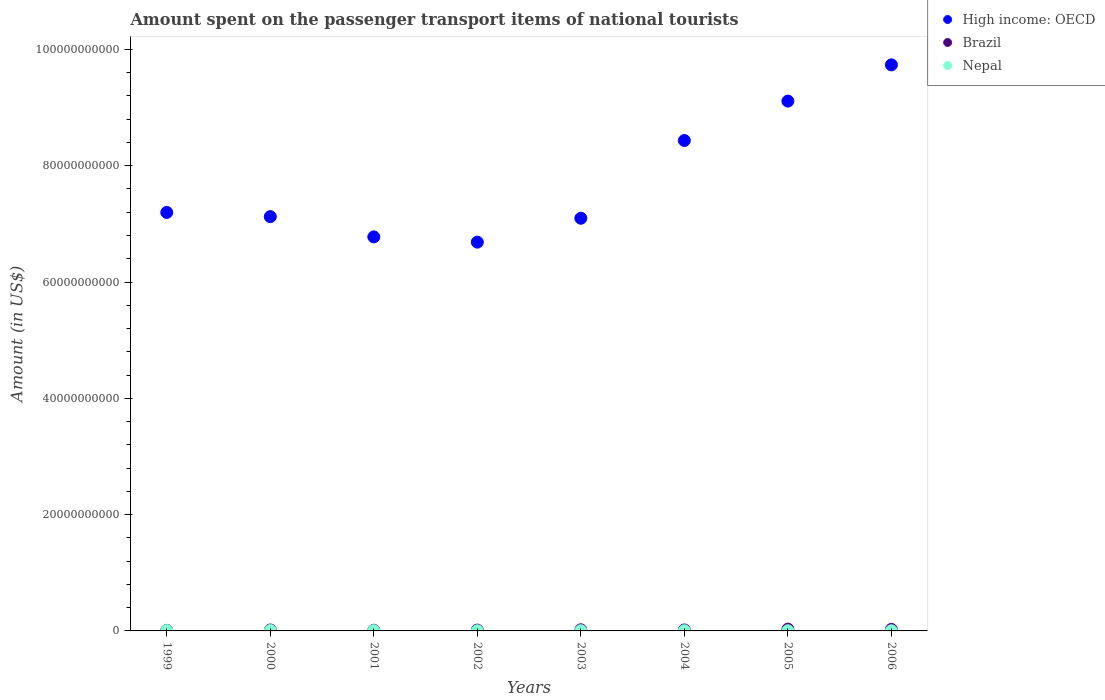Is the number of dotlines equal to the number of legend labels?
Provide a short and direct response. Yes. What is the amount spent on the passenger transport items of national tourists in High income: OECD in 2005?
Ensure brevity in your answer.  9.11e+1. Across all years, what is the maximum amount spent on the passenger transport items of national tourists in Nepal?
Offer a very short reply. 6.10e+07. Across all years, what is the minimum amount spent on the passenger transport items of national tourists in High income: OECD?
Keep it short and to the point. 6.69e+1. In which year was the amount spent on the passenger transport items of national tourists in Brazil maximum?
Offer a very short reply. 2005. What is the total amount spent on the passenger transport items of national tourists in Nepal in the graph?
Your answer should be compact. 3.16e+08. What is the difference between the amount spent on the passenger transport items of national tourists in Nepal in 2003 and that in 2005?
Provide a short and direct response. 4.00e+06. What is the difference between the amount spent on the passenger transport items of national tourists in Nepal in 2004 and the amount spent on the passenger transport items of national tourists in Brazil in 2003?
Your answer should be compact. -1.64e+08. What is the average amount spent on the passenger transport items of national tourists in Nepal per year?
Offer a very short reply. 3.95e+07. In the year 2003, what is the difference between the amount spent on the passenger transport items of national tourists in Brazil and amount spent on the passenger transport items of national tourists in High income: OECD?
Your answer should be compact. -7.08e+1. What is the ratio of the amount spent on the passenger transport items of national tourists in Nepal in 2002 to that in 2004?
Provide a short and direct response. 1.03. Is the amount spent on the passenger transport items of national tourists in High income: OECD in 2002 less than that in 2006?
Your answer should be compact. Yes. What is the difference between the highest and the second highest amount spent on the passenger transport items of national tourists in Nepal?
Make the answer very short. 5.00e+06. What is the difference between the highest and the lowest amount spent on the passenger transport items of national tourists in Nepal?
Your answer should be very brief. 3.20e+07. In how many years, is the amount spent on the passenger transport items of national tourists in High income: OECD greater than the average amount spent on the passenger transport items of national tourists in High income: OECD taken over all years?
Your response must be concise. 3. Is it the case that in every year, the sum of the amount spent on the passenger transport items of national tourists in Nepal and amount spent on the passenger transport items of national tourists in Brazil  is greater than the amount spent on the passenger transport items of national tourists in High income: OECD?
Offer a very short reply. No. Does the amount spent on the passenger transport items of national tourists in Brazil monotonically increase over the years?
Keep it short and to the point. No. Is the amount spent on the passenger transport items of national tourists in Brazil strictly greater than the amount spent on the passenger transport items of national tourists in High income: OECD over the years?
Provide a succinct answer. No. Is the amount spent on the passenger transport items of national tourists in Nepal strictly less than the amount spent on the passenger transport items of national tourists in Brazil over the years?
Your answer should be compact. Yes. How many dotlines are there?
Offer a very short reply. 3. Does the graph contain any zero values?
Ensure brevity in your answer.  No. Where does the legend appear in the graph?
Your answer should be very brief. Top right. How are the legend labels stacked?
Your response must be concise. Vertical. What is the title of the graph?
Your response must be concise. Amount spent on the passenger transport items of national tourists. Does "Upper middle income" appear as one of the legend labels in the graph?
Offer a very short reply. No. What is the label or title of the X-axis?
Provide a succinct answer. Years. What is the Amount (in US$) in High income: OECD in 1999?
Provide a succinct answer. 7.20e+1. What is the Amount (in US$) in Brazil in 1999?
Keep it short and to the point. 9.20e+07. What is the Amount (in US$) in Nepal in 1999?
Keep it short and to the point. 5.60e+07. What is the Amount (in US$) of High income: OECD in 2000?
Provide a short and direct response. 7.12e+1. What is the Amount (in US$) of Brazil in 2000?
Offer a very short reply. 1.59e+08. What is the Amount (in US$) in Nepal in 2000?
Your answer should be very brief. 6.10e+07. What is the Amount (in US$) in High income: OECD in 2001?
Keep it short and to the point. 6.78e+1. What is the Amount (in US$) in Brazil in 2001?
Make the answer very short. 1.13e+08. What is the Amount (in US$) in Nepal in 2001?
Offer a very short reply. 4.70e+07. What is the Amount (in US$) of High income: OECD in 2002?
Offer a very short reply. 6.69e+1. What is the Amount (in US$) of Brazil in 2002?
Keep it short and to the point. 1.44e+08. What is the Amount (in US$) of Nepal in 2002?
Your answer should be very brief. 3.10e+07. What is the Amount (in US$) of High income: OECD in 2003?
Your answer should be compact. 7.10e+1. What is the Amount (in US$) of Brazil in 2003?
Your answer should be compact. 1.94e+08. What is the Amount (in US$) in Nepal in 2003?
Ensure brevity in your answer.  3.30e+07. What is the Amount (in US$) in High income: OECD in 2004?
Your answer should be very brief. 8.43e+1. What is the Amount (in US$) in Brazil in 2004?
Ensure brevity in your answer.  1.67e+08. What is the Amount (in US$) in Nepal in 2004?
Keep it short and to the point. 3.00e+07. What is the Amount (in US$) in High income: OECD in 2005?
Your answer should be very brief. 9.11e+1. What is the Amount (in US$) of Brazil in 2005?
Keep it short and to the point. 3.07e+08. What is the Amount (in US$) of Nepal in 2005?
Offer a terse response. 2.90e+07. What is the Amount (in US$) in High income: OECD in 2006?
Offer a terse response. 9.73e+1. What is the Amount (in US$) in Brazil in 2006?
Offer a very short reply. 2.61e+08. What is the Amount (in US$) of Nepal in 2006?
Keep it short and to the point. 2.90e+07. Across all years, what is the maximum Amount (in US$) in High income: OECD?
Provide a succinct answer. 9.73e+1. Across all years, what is the maximum Amount (in US$) of Brazil?
Your answer should be very brief. 3.07e+08. Across all years, what is the maximum Amount (in US$) of Nepal?
Make the answer very short. 6.10e+07. Across all years, what is the minimum Amount (in US$) in High income: OECD?
Give a very brief answer. 6.69e+1. Across all years, what is the minimum Amount (in US$) of Brazil?
Your response must be concise. 9.20e+07. Across all years, what is the minimum Amount (in US$) of Nepal?
Your answer should be compact. 2.90e+07. What is the total Amount (in US$) in High income: OECD in the graph?
Provide a succinct answer. 6.22e+11. What is the total Amount (in US$) of Brazil in the graph?
Your answer should be compact. 1.44e+09. What is the total Amount (in US$) in Nepal in the graph?
Ensure brevity in your answer.  3.16e+08. What is the difference between the Amount (in US$) in High income: OECD in 1999 and that in 2000?
Your response must be concise. 7.22e+08. What is the difference between the Amount (in US$) in Brazil in 1999 and that in 2000?
Ensure brevity in your answer.  -6.70e+07. What is the difference between the Amount (in US$) of Nepal in 1999 and that in 2000?
Your response must be concise. -5.00e+06. What is the difference between the Amount (in US$) of High income: OECD in 1999 and that in 2001?
Provide a succinct answer. 4.20e+09. What is the difference between the Amount (in US$) in Brazil in 1999 and that in 2001?
Provide a short and direct response. -2.10e+07. What is the difference between the Amount (in US$) in Nepal in 1999 and that in 2001?
Give a very brief answer. 9.00e+06. What is the difference between the Amount (in US$) in High income: OECD in 1999 and that in 2002?
Offer a very short reply. 5.10e+09. What is the difference between the Amount (in US$) of Brazil in 1999 and that in 2002?
Offer a very short reply. -5.20e+07. What is the difference between the Amount (in US$) of Nepal in 1999 and that in 2002?
Give a very brief answer. 2.50e+07. What is the difference between the Amount (in US$) of High income: OECD in 1999 and that in 2003?
Offer a very short reply. 9.96e+08. What is the difference between the Amount (in US$) of Brazil in 1999 and that in 2003?
Make the answer very short. -1.02e+08. What is the difference between the Amount (in US$) of Nepal in 1999 and that in 2003?
Offer a very short reply. 2.30e+07. What is the difference between the Amount (in US$) of High income: OECD in 1999 and that in 2004?
Provide a succinct answer. -1.24e+1. What is the difference between the Amount (in US$) in Brazil in 1999 and that in 2004?
Offer a terse response. -7.50e+07. What is the difference between the Amount (in US$) of Nepal in 1999 and that in 2004?
Offer a very short reply. 2.60e+07. What is the difference between the Amount (in US$) of High income: OECD in 1999 and that in 2005?
Ensure brevity in your answer.  -1.91e+1. What is the difference between the Amount (in US$) in Brazil in 1999 and that in 2005?
Ensure brevity in your answer.  -2.15e+08. What is the difference between the Amount (in US$) in Nepal in 1999 and that in 2005?
Offer a terse response. 2.70e+07. What is the difference between the Amount (in US$) of High income: OECD in 1999 and that in 2006?
Offer a very short reply. -2.54e+1. What is the difference between the Amount (in US$) of Brazil in 1999 and that in 2006?
Offer a terse response. -1.69e+08. What is the difference between the Amount (in US$) of Nepal in 1999 and that in 2006?
Make the answer very short. 2.70e+07. What is the difference between the Amount (in US$) in High income: OECD in 2000 and that in 2001?
Your response must be concise. 3.48e+09. What is the difference between the Amount (in US$) in Brazil in 2000 and that in 2001?
Keep it short and to the point. 4.60e+07. What is the difference between the Amount (in US$) of Nepal in 2000 and that in 2001?
Make the answer very short. 1.40e+07. What is the difference between the Amount (in US$) in High income: OECD in 2000 and that in 2002?
Offer a terse response. 4.38e+09. What is the difference between the Amount (in US$) in Brazil in 2000 and that in 2002?
Your response must be concise. 1.50e+07. What is the difference between the Amount (in US$) in Nepal in 2000 and that in 2002?
Provide a succinct answer. 3.00e+07. What is the difference between the Amount (in US$) in High income: OECD in 2000 and that in 2003?
Your answer should be very brief. 2.74e+08. What is the difference between the Amount (in US$) of Brazil in 2000 and that in 2003?
Provide a short and direct response. -3.50e+07. What is the difference between the Amount (in US$) of Nepal in 2000 and that in 2003?
Your response must be concise. 2.80e+07. What is the difference between the Amount (in US$) in High income: OECD in 2000 and that in 2004?
Offer a terse response. -1.31e+1. What is the difference between the Amount (in US$) of Brazil in 2000 and that in 2004?
Provide a short and direct response. -8.00e+06. What is the difference between the Amount (in US$) in Nepal in 2000 and that in 2004?
Make the answer very short. 3.10e+07. What is the difference between the Amount (in US$) of High income: OECD in 2000 and that in 2005?
Provide a short and direct response. -1.99e+1. What is the difference between the Amount (in US$) in Brazil in 2000 and that in 2005?
Keep it short and to the point. -1.48e+08. What is the difference between the Amount (in US$) of Nepal in 2000 and that in 2005?
Your response must be concise. 3.20e+07. What is the difference between the Amount (in US$) of High income: OECD in 2000 and that in 2006?
Keep it short and to the point. -2.61e+1. What is the difference between the Amount (in US$) of Brazil in 2000 and that in 2006?
Your answer should be very brief. -1.02e+08. What is the difference between the Amount (in US$) of Nepal in 2000 and that in 2006?
Offer a terse response. 3.20e+07. What is the difference between the Amount (in US$) in High income: OECD in 2001 and that in 2002?
Provide a short and direct response. 9.02e+08. What is the difference between the Amount (in US$) of Brazil in 2001 and that in 2002?
Ensure brevity in your answer.  -3.10e+07. What is the difference between the Amount (in US$) of Nepal in 2001 and that in 2002?
Give a very brief answer. 1.60e+07. What is the difference between the Amount (in US$) in High income: OECD in 2001 and that in 2003?
Keep it short and to the point. -3.21e+09. What is the difference between the Amount (in US$) in Brazil in 2001 and that in 2003?
Ensure brevity in your answer.  -8.10e+07. What is the difference between the Amount (in US$) in Nepal in 2001 and that in 2003?
Offer a terse response. 1.40e+07. What is the difference between the Amount (in US$) in High income: OECD in 2001 and that in 2004?
Provide a short and direct response. -1.66e+1. What is the difference between the Amount (in US$) of Brazil in 2001 and that in 2004?
Offer a very short reply. -5.40e+07. What is the difference between the Amount (in US$) in Nepal in 2001 and that in 2004?
Offer a very short reply. 1.70e+07. What is the difference between the Amount (in US$) in High income: OECD in 2001 and that in 2005?
Make the answer very short. -2.34e+1. What is the difference between the Amount (in US$) in Brazil in 2001 and that in 2005?
Ensure brevity in your answer.  -1.94e+08. What is the difference between the Amount (in US$) in Nepal in 2001 and that in 2005?
Ensure brevity in your answer.  1.80e+07. What is the difference between the Amount (in US$) in High income: OECD in 2001 and that in 2006?
Offer a very short reply. -2.96e+1. What is the difference between the Amount (in US$) in Brazil in 2001 and that in 2006?
Give a very brief answer. -1.48e+08. What is the difference between the Amount (in US$) in Nepal in 2001 and that in 2006?
Ensure brevity in your answer.  1.80e+07. What is the difference between the Amount (in US$) of High income: OECD in 2002 and that in 2003?
Offer a terse response. -4.11e+09. What is the difference between the Amount (in US$) in Brazil in 2002 and that in 2003?
Offer a terse response. -5.00e+07. What is the difference between the Amount (in US$) in High income: OECD in 2002 and that in 2004?
Offer a very short reply. -1.75e+1. What is the difference between the Amount (in US$) in Brazil in 2002 and that in 2004?
Provide a short and direct response. -2.30e+07. What is the difference between the Amount (in US$) in High income: OECD in 2002 and that in 2005?
Provide a succinct answer. -2.43e+1. What is the difference between the Amount (in US$) in Brazil in 2002 and that in 2005?
Provide a short and direct response. -1.63e+08. What is the difference between the Amount (in US$) in High income: OECD in 2002 and that in 2006?
Provide a short and direct response. -3.05e+1. What is the difference between the Amount (in US$) of Brazil in 2002 and that in 2006?
Provide a succinct answer. -1.17e+08. What is the difference between the Amount (in US$) in Nepal in 2002 and that in 2006?
Provide a short and direct response. 2.00e+06. What is the difference between the Amount (in US$) in High income: OECD in 2003 and that in 2004?
Your answer should be very brief. -1.34e+1. What is the difference between the Amount (in US$) in Brazil in 2003 and that in 2004?
Give a very brief answer. 2.70e+07. What is the difference between the Amount (in US$) of High income: OECD in 2003 and that in 2005?
Offer a terse response. -2.01e+1. What is the difference between the Amount (in US$) in Brazil in 2003 and that in 2005?
Provide a succinct answer. -1.13e+08. What is the difference between the Amount (in US$) of High income: OECD in 2003 and that in 2006?
Provide a short and direct response. -2.64e+1. What is the difference between the Amount (in US$) in Brazil in 2003 and that in 2006?
Offer a very short reply. -6.70e+07. What is the difference between the Amount (in US$) of High income: OECD in 2004 and that in 2005?
Your answer should be compact. -6.77e+09. What is the difference between the Amount (in US$) in Brazil in 2004 and that in 2005?
Offer a terse response. -1.40e+08. What is the difference between the Amount (in US$) of High income: OECD in 2004 and that in 2006?
Give a very brief answer. -1.30e+1. What is the difference between the Amount (in US$) of Brazil in 2004 and that in 2006?
Keep it short and to the point. -9.40e+07. What is the difference between the Amount (in US$) in Nepal in 2004 and that in 2006?
Offer a very short reply. 1.00e+06. What is the difference between the Amount (in US$) of High income: OECD in 2005 and that in 2006?
Make the answer very short. -6.23e+09. What is the difference between the Amount (in US$) of Brazil in 2005 and that in 2006?
Make the answer very short. 4.60e+07. What is the difference between the Amount (in US$) in Nepal in 2005 and that in 2006?
Your response must be concise. 0. What is the difference between the Amount (in US$) of High income: OECD in 1999 and the Amount (in US$) of Brazil in 2000?
Your answer should be very brief. 7.18e+1. What is the difference between the Amount (in US$) of High income: OECD in 1999 and the Amount (in US$) of Nepal in 2000?
Ensure brevity in your answer.  7.19e+1. What is the difference between the Amount (in US$) of Brazil in 1999 and the Amount (in US$) of Nepal in 2000?
Provide a short and direct response. 3.10e+07. What is the difference between the Amount (in US$) of High income: OECD in 1999 and the Amount (in US$) of Brazil in 2001?
Offer a terse response. 7.19e+1. What is the difference between the Amount (in US$) in High income: OECD in 1999 and the Amount (in US$) in Nepal in 2001?
Give a very brief answer. 7.19e+1. What is the difference between the Amount (in US$) of Brazil in 1999 and the Amount (in US$) of Nepal in 2001?
Ensure brevity in your answer.  4.50e+07. What is the difference between the Amount (in US$) of High income: OECD in 1999 and the Amount (in US$) of Brazil in 2002?
Make the answer very short. 7.18e+1. What is the difference between the Amount (in US$) of High income: OECD in 1999 and the Amount (in US$) of Nepal in 2002?
Your response must be concise. 7.19e+1. What is the difference between the Amount (in US$) in Brazil in 1999 and the Amount (in US$) in Nepal in 2002?
Provide a succinct answer. 6.10e+07. What is the difference between the Amount (in US$) in High income: OECD in 1999 and the Amount (in US$) in Brazil in 2003?
Your answer should be compact. 7.18e+1. What is the difference between the Amount (in US$) of High income: OECD in 1999 and the Amount (in US$) of Nepal in 2003?
Offer a very short reply. 7.19e+1. What is the difference between the Amount (in US$) in Brazil in 1999 and the Amount (in US$) in Nepal in 2003?
Make the answer very short. 5.90e+07. What is the difference between the Amount (in US$) in High income: OECD in 1999 and the Amount (in US$) in Brazil in 2004?
Your answer should be compact. 7.18e+1. What is the difference between the Amount (in US$) in High income: OECD in 1999 and the Amount (in US$) in Nepal in 2004?
Your answer should be very brief. 7.19e+1. What is the difference between the Amount (in US$) in Brazil in 1999 and the Amount (in US$) in Nepal in 2004?
Provide a succinct answer. 6.20e+07. What is the difference between the Amount (in US$) in High income: OECD in 1999 and the Amount (in US$) in Brazil in 2005?
Provide a short and direct response. 7.17e+1. What is the difference between the Amount (in US$) of High income: OECD in 1999 and the Amount (in US$) of Nepal in 2005?
Keep it short and to the point. 7.19e+1. What is the difference between the Amount (in US$) of Brazil in 1999 and the Amount (in US$) of Nepal in 2005?
Keep it short and to the point. 6.30e+07. What is the difference between the Amount (in US$) of High income: OECD in 1999 and the Amount (in US$) of Brazil in 2006?
Provide a short and direct response. 7.17e+1. What is the difference between the Amount (in US$) in High income: OECD in 1999 and the Amount (in US$) in Nepal in 2006?
Your answer should be compact. 7.19e+1. What is the difference between the Amount (in US$) in Brazil in 1999 and the Amount (in US$) in Nepal in 2006?
Provide a short and direct response. 6.30e+07. What is the difference between the Amount (in US$) in High income: OECD in 2000 and the Amount (in US$) in Brazil in 2001?
Your response must be concise. 7.11e+1. What is the difference between the Amount (in US$) of High income: OECD in 2000 and the Amount (in US$) of Nepal in 2001?
Provide a short and direct response. 7.12e+1. What is the difference between the Amount (in US$) in Brazil in 2000 and the Amount (in US$) in Nepal in 2001?
Provide a short and direct response. 1.12e+08. What is the difference between the Amount (in US$) of High income: OECD in 2000 and the Amount (in US$) of Brazil in 2002?
Your response must be concise. 7.11e+1. What is the difference between the Amount (in US$) in High income: OECD in 2000 and the Amount (in US$) in Nepal in 2002?
Make the answer very short. 7.12e+1. What is the difference between the Amount (in US$) of Brazil in 2000 and the Amount (in US$) of Nepal in 2002?
Your answer should be compact. 1.28e+08. What is the difference between the Amount (in US$) of High income: OECD in 2000 and the Amount (in US$) of Brazil in 2003?
Your answer should be compact. 7.10e+1. What is the difference between the Amount (in US$) of High income: OECD in 2000 and the Amount (in US$) of Nepal in 2003?
Keep it short and to the point. 7.12e+1. What is the difference between the Amount (in US$) in Brazil in 2000 and the Amount (in US$) in Nepal in 2003?
Make the answer very short. 1.26e+08. What is the difference between the Amount (in US$) in High income: OECD in 2000 and the Amount (in US$) in Brazil in 2004?
Provide a short and direct response. 7.11e+1. What is the difference between the Amount (in US$) in High income: OECD in 2000 and the Amount (in US$) in Nepal in 2004?
Keep it short and to the point. 7.12e+1. What is the difference between the Amount (in US$) in Brazil in 2000 and the Amount (in US$) in Nepal in 2004?
Offer a terse response. 1.29e+08. What is the difference between the Amount (in US$) of High income: OECD in 2000 and the Amount (in US$) of Brazil in 2005?
Ensure brevity in your answer.  7.09e+1. What is the difference between the Amount (in US$) in High income: OECD in 2000 and the Amount (in US$) in Nepal in 2005?
Your answer should be very brief. 7.12e+1. What is the difference between the Amount (in US$) of Brazil in 2000 and the Amount (in US$) of Nepal in 2005?
Your response must be concise. 1.30e+08. What is the difference between the Amount (in US$) in High income: OECD in 2000 and the Amount (in US$) in Brazil in 2006?
Ensure brevity in your answer.  7.10e+1. What is the difference between the Amount (in US$) of High income: OECD in 2000 and the Amount (in US$) of Nepal in 2006?
Ensure brevity in your answer.  7.12e+1. What is the difference between the Amount (in US$) of Brazil in 2000 and the Amount (in US$) of Nepal in 2006?
Provide a succinct answer. 1.30e+08. What is the difference between the Amount (in US$) of High income: OECD in 2001 and the Amount (in US$) of Brazil in 2002?
Ensure brevity in your answer.  6.76e+1. What is the difference between the Amount (in US$) of High income: OECD in 2001 and the Amount (in US$) of Nepal in 2002?
Ensure brevity in your answer.  6.77e+1. What is the difference between the Amount (in US$) in Brazil in 2001 and the Amount (in US$) in Nepal in 2002?
Offer a terse response. 8.20e+07. What is the difference between the Amount (in US$) in High income: OECD in 2001 and the Amount (in US$) in Brazil in 2003?
Make the answer very short. 6.76e+1. What is the difference between the Amount (in US$) in High income: OECD in 2001 and the Amount (in US$) in Nepal in 2003?
Offer a terse response. 6.77e+1. What is the difference between the Amount (in US$) in Brazil in 2001 and the Amount (in US$) in Nepal in 2003?
Your answer should be very brief. 8.00e+07. What is the difference between the Amount (in US$) in High income: OECD in 2001 and the Amount (in US$) in Brazil in 2004?
Offer a very short reply. 6.76e+1. What is the difference between the Amount (in US$) of High income: OECD in 2001 and the Amount (in US$) of Nepal in 2004?
Your answer should be very brief. 6.77e+1. What is the difference between the Amount (in US$) in Brazil in 2001 and the Amount (in US$) in Nepal in 2004?
Your response must be concise. 8.30e+07. What is the difference between the Amount (in US$) of High income: OECD in 2001 and the Amount (in US$) of Brazil in 2005?
Keep it short and to the point. 6.75e+1. What is the difference between the Amount (in US$) of High income: OECD in 2001 and the Amount (in US$) of Nepal in 2005?
Make the answer very short. 6.77e+1. What is the difference between the Amount (in US$) of Brazil in 2001 and the Amount (in US$) of Nepal in 2005?
Provide a short and direct response. 8.40e+07. What is the difference between the Amount (in US$) in High income: OECD in 2001 and the Amount (in US$) in Brazil in 2006?
Ensure brevity in your answer.  6.75e+1. What is the difference between the Amount (in US$) of High income: OECD in 2001 and the Amount (in US$) of Nepal in 2006?
Your response must be concise. 6.77e+1. What is the difference between the Amount (in US$) of Brazil in 2001 and the Amount (in US$) of Nepal in 2006?
Offer a terse response. 8.40e+07. What is the difference between the Amount (in US$) in High income: OECD in 2002 and the Amount (in US$) in Brazil in 2003?
Keep it short and to the point. 6.67e+1. What is the difference between the Amount (in US$) of High income: OECD in 2002 and the Amount (in US$) of Nepal in 2003?
Your response must be concise. 6.68e+1. What is the difference between the Amount (in US$) of Brazil in 2002 and the Amount (in US$) of Nepal in 2003?
Offer a very short reply. 1.11e+08. What is the difference between the Amount (in US$) of High income: OECD in 2002 and the Amount (in US$) of Brazil in 2004?
Offer a very short reply. 6.67e+1. What is the difference between the Amount (in US$) of High income: OECD in 2002 and the Amount (in US$) of Nepal in 2004?
Ensure brevity in your answer.  6.68e+1. What is the difference between the Amount (in US$) of Brazil in 2002 and the Amount (in US$) of Nepal in 2004?
Give a very brief answer. 1.14e+08. What is the difference between the Amount (in US$) in High income: OECD in 2002 and the Amount (in US$) in Brazil in 2005?
Keep it short and to the point. 6.66e+1. What is the difference between the Amount (in US$) in High income: OECD in 2002 and the Amount (in US$) in Nepal in 2005?
Provide a short and direct response. 6.68e+1. What is the difference between the Amount (in US$) in Brazil in 2002 and the Amount (in US$) in Nepal in 2005?
Your answer should be very brief. 1.15e+08. What is the difference between the Amount (in US$) of High income: OECD in 2002 and the Amount (in US$) of Brazil in 2006?
Keep it short and to the point. 6.66e+1. What is the difference between the Amount (in US$) of High income: OECD in 2002 and the Amount (in US$) of Nepal in 2006?
Offer a very short reply. 6.68e+1. What is the difference between the Amount (in US$) in Brazil in 2002 and the Amount (in US$) in Nepal in 2006?
Your answer should be compact. 1.15e+08. What is the difference between the Amount (in US$) in High income: OECD in 2003 and the Amount (in US$) in Brazil in 2004?
Your response must be concise. 7.08e+1. What is the difference between the Amount (in US$) in High income: OECD in 2003 and the Amount (in US$) in Nepal in 2004?
Your answer should be very brief. 7.09e+1. What is the difference between the Amount (in US$) of Brazil in 2003 and the Amount (in US$) of Nepal in 2004?
Your response must be concise. 1.64e+08. What is the difference between the Amount (in US$) in High income: OECD in 2003 and the Amount (in US$) in Brazil in 2005?
Make the answer very short. 7.07e+1. What is the difference between the Amount (in US$) of High income: OECD in 2003 and the Amount (in US$) of Nepal in 2005?
Ensure brevity in your answer.  7.09e+1. What is the difference between the Amount (in US$) in Brazil in 2003 and the Amount (in US$) in Nepal in 2005?
Make the answer very short. 1.65e+08. What is the difference between the Amount (in US$) in High income: OECD in 2003 and the Amount (in US$) in Brazil in 2006?
Keep it short and to the point. 7.07e+1. What is the difference between the Amount (in US$) in High income: OECD in 2003 and the Amount (in US$) in Nepal in 2006?
Keep it short and to the point. 7.09e+1. What is the difference between the Amount (in US$) in Brazil in 2003 and the Amount (in US$) in Nepal in 2006?
Make the answer very short. 1.65e+08. What is the difference between the Amount (in US$) of High income: OECD in 2004 and the Amount (in US$) of Brazil in 2005?
Your response must be concise. 8.40e+1. What is the difference between the Amount (in US$) of High income: OECD in 2004 and the Amount (in US$) of Nepal in 2005?
Make the answer very short. 8.43e+1. What is the difference between the Amount (in US$) in Brazil in 2004 and the Amount (in US$) in Nepal in 2005?
Provide a succinct answer. 1.38e+08. What is the difference between the Amount (in US$) of High income: OECD in 2004 and the Amount (in US$) of Brazil in 2006?
Your answer should be very brief. 8.41e+1. What is the difference between the Amount (in US$) in High income: OECD in 2004 and the Amount (in US$) in Nepal in 2006?
Give a very brief answer. 8.43e+1. What is the difference between the Amount (in US$) of Brazil in 2004 and the Amount (in US$) of Nepal in 2006?
Your answer should be compact. 1.38e+08. What is the difference between the Amount (in US$) in High income: OECD in 2005 and the Amount (in US$) in Brazil in 2006?
Give a very brief answer. 9.09e+1. What is the difference between the Amount (in US$) of High income: OECD in 2005 and the Amount (in US$) of Nepal in 2006?
Your response must be concise. 9.11e+1. What is the difference between the Amount (in US$) in Brazil in 2005 and the Amount (in US$) in Nepal in 2006?
Your answer should be compact. 2.78e+08. What is the average Amount (in US$) in High income: OECD per year?
Your response must be concise. 7.77e+1. What is the average Amount (in US$) in Brazil per year?
Ensure brevity in your answer.  1.80e+08. What is the average Amount (in US$) of Nepal per year?
Give a very brief answer. 3.95e+07. In the year 1999, what is the difference between the Amount (in US$) in High income: OECD and Amount (in US$) in Brazil?
Offer a terse response. 7.19e+1. In the year 1999, what is the difference between the Amount (in US$) of High income: OECD and Amount (in US$) of Nepal?
Offer a terse response. 7.19e+1. In the year 1999, what is the difference between the Amount (in US$) of Brazil and Amount (in US$) of Nepal?
Your response must be concise. 3.60e+07. In the year 2000, what is the difference between the Amount (in US$) of High income: OECD and Amount (in US$) of Brazil?
Your response must be concise. 7.11e+1. In the year 2000, what is the difference between the Amount (in US$) of High income: OECD and Amount (in US$) of Nepal?
Offer a very short reply. 7.12e+1. In the year 2000, what is the difference between the Amount (in US$) in Brazil and Amount (in US$) in Nepal?
Make the answer very short. 9.80e+07. In the year 2001, what is the difference between the Amount (in US$) in High income: OECD and Amount (in US$) in Brazil?
Your response must be concise. 6.76e+1. In the year 2001, what is the difference between the Amount (in US$) in High income: OECD and Amount (in US$) in Nepal?
Your answer should be compact. 6.77e+1. In the year 2001, what is the difference between the Amount (in US$) in Brazil and Amount (in US$) in Nepal?
Your response must be concise. 6.60e+07. In the year 2002, what is the difference between the Amount (in US$) of High income: OECD and Amount (in US$) of Brazil?
Your answer should be very brief. 6.67e+1. In the year 2002, what is the difference between the Amount (in US$) in High income: OECD and Amount (in US$) in Nepal?
Ensure brevity in your answer.  6.68e+1. In the year 2002, what is the difference between the Amount (in US$) of Brazil and Amount (in US$) of Nepal?
Provide a short and direct response. 1.13e+08. In the year 2003, what is the difference between the Amount (in US$) in High income: OECD and Amount (in US$) in Brazil?
Your answer should be compact. 7.08e+1. In the year 2003, what is the difference between the Amount (in US$) in High income: OECD and Amount (in US$) in Nepal?
Your response must be concise. 7.09e+1. In the year 2003, what is the difference between the Amount (in US$) of Brazil and Amount (in US$) of Nepal?
Provide a succinct answer. 1.61e+08. In the year 2004, what is the difference between the Amount (in US$) of High income: OECD and Amount (in US$) of Brazil?
Keep it short and to the point. 8.42e+1. In the year 2004, what is the difference between the Amount (in US$) of High income: OECD and Amount (in US$) of Nepal?
Give a very brief answer. 8.43e+1. In the year 2004, what is the difference between the Amount (in US$) of Brazil and Amount (in US$) of Nepal?
Offer a very short reply. 1.37e+08. In the year 2005, what is the difference between the Amount (in US$) of High income: OECD and Amount (in US$) of Brazil?
Give a very brief answer. 9.08e+1. In the year 2005, what is the difference between the Amount (in US$) in High income: OECD and Amount (in US$) in Nepal?
Your answer should be compact. 9.11e+1. In the year 2005, what is the difference between the Amount (in US$) of Brazil and Amount (in US$) of Nepal?
Ensure brevity in your answer.  2.78e+08. In the year 2006, what is the difference between the Amount (in US$) in High income: OECD and Amount (in US$) in Brazil?
Your answer should be compact. 9.71e+1. In the year 2006, what is the difference between the Amount (in US$) in High income: OECD and Amount (in US$) in Nepal?
Ensure brevity in your answer.  9.73e+1. In the year 2006, what is the difference between the Amount (in US$) of Brazil and Amount (in US$) of Nepal?
Provide a short and direct response. 2.32e+08. What is the ratio of the Amount (in US$) in Brazil in 1999 to that in 2000?
Make the answer very short. 0.58. What is the ratio of the Amount (in US$) of Nepal in 1999 to that in 2000?
Give a very brief answer. 0.92. What is the ratio of the Amount (in US$) of High income: OECD in 1999 to that in 2001?
Your response must be concise. 1.06. What is the ratio of the Amount (in US$) of Brazil in 1999 to that in 2001?
Give a very brief answer. 0.81. What is the ratio of the Amount (in US$) in Nepal in 1999 to that in 2001?
Offer a very short reply. 1.19. What is the ratio of the Amount (in US$) in High income: OECD in 1999 to that in 2002?
Your answer should be compact. 1.08. What is the ratio of the Amount (in US$) of Brazil in 1999 to that in 2002?
Provide a short and direct response. 0.64. What is the ratio of the Amount (in US$) in Nepal in 1999 to that in 2002?
Give a very brief answer. 1.81. What is the ratio of the Amount (in US$) of High income: OECD in 1999 to that in 2003?
Offer a very short reply. 1.01. What is the ratio of the Amount (in US$) in Brazil in 1999 to that in 2003?
Your answer should be very brief. 0.47. What is the ratio of the Amount (in US$) of Nepal in 1999 to that in 2003?
Give a very brief answer. 1.7. What is the ratio of the Amount (in US$) of High income: OECD in 1999 to that in 2004?
Your answer should be compact. 0.85. What is the ratio of the Amount (in US$) of Brazil in 1999 to that in 2004?
Provide a short and direct response. 0.55. What is the ratio of the Amount (in US$) of Nepal in 1999 to that in 2004?
Provide a short and direct response. 1.87. What is the ratio of the Amount (in US$) of High income: OECD in 1999 to that in 2005?
Offer a very short reply. 0.79. What is the ratio of the Amount (in US$) in Brazil in 1999 to that in 2005?
Your response must be concise. 0.3. What is the ratio of the Amount (in US$) in Nepal in 1999 to that in 2005?
Offer a very short reply. 1.93. What is the ratio of the Amount (in US$) of High income: OECD in 1999 to that in 2006?
Offer a very short reply. 0.74. What is the ratio of the Amount (in US$) of Brazil in 1999 to that in 2006?
Ensure brevity in your answer.  0.35. What is the ratio of the Amount (in US$) in Nepal in 1999 to that in 2006?
Your response must be concise. 1.93. What is the ratio of the Amount (in US$) of High income: OECD in 2000 to that in 2001?
Keep it short and to the point. 1.05. What is the ratio of the Amount (in US$) of Brazil in 2000 to that in 2001?
Offer a terse response. 1.41. What is the ratio of the Amount (in US$) of Nepal in 2000 to that in 2001?
Keep it short and to the point. 1.3. What is the ratio of the Amount (in US$) in High income: OECD in 2000 to that in 2002?
Provide a succinct answer. 1.07. What is the ratio of the Amount (in US$) in Brazil in 2000 to that in 2002?
Make the answer very short. 1.1. What is the ratio of the Amount (in US$) in Nepal in 2000 to that in 2002?
Your answer should be compact. 1.97. What is the ratio of the Amount (in US$) in Brazil in 2000 to that in 2003?
Keep it short and to the point. 0.82. What is the ratio of the Amount (in US$) of Nepal in 2000 to that in 2003?
Provide a succinct answer. 1.85. What is the ratio of the Amount (in US$) of High income: OECD in 2000 to that in 2004?
Your response must be concise. 0.84. What is the ratio of the Amount (in US$) in Brazil in 2000 to that in 2004?
Provide a short and direct response. 0.95. What is the ratio of the Amount (in US$) in Nepal in 2000 to that in 2004?
Your answer should be very brief. 2.03. What is the ratio of the Amount (in US$) of High income: OECD in 2000 to that in 2005?
Ensure brevity in your answer.  0.78. What is the ratio of the Amount (in US$) of Brazil in 2000 to that in 2005?
Provide a short and direct response. 0.52. What is the ratio of the Amount (in US$) in Nepal in 2000 to that in 2005?
Offer a very short reply. 2.1. What is the ratio of the Amount (in US$) in High income: OECD in 2000 to that in 2006?
Offer a very short reply. 0.73. What is the ratio of the Amount (in US$) of Brazil in 2000 to that in 2006?
Your response must be concise. 0.61. What is the ratio of the Amount (in US$) of Nepal in 2000 to that in 2006?
Make the answer very short. 2.1. What is the ratio of the Amount (in US$) of High income: OECD in 2001 to that in 2002?
Your answer should be compact. 1.01. What is the ratio of the Amount (in US$) in Brazil in 2001 to that in 2002?
Make the answer very short. 0.78. What is the ratio of the Amount (in US$) in Nepal in 2001 to that in 2002?
Keep it short and to the point. 1.52. What is the ratio of the Amount (in US$) in High income: OECD in 2001 to that in 2003?
Your answer should be very brief. 0.95. What is the ratio of the Amount (in US$) of Brazil in 2001 to that in 2003?
Keep it short and to the point. 0.58. What is the ratio of the Amount (in US$) in Nepal in 2001 to that in 2003?
Offer a very short reply. 1.42. What is the ratio of the Amount (in US$) in High income: OECD in 2001 to that in 2004?
Your answer should be compact. 0.8. What is the ratio of the Amount (in US$) in Brazil in 2001 to that in 2004?
Make the answer very short. 0.68. What is the ratio of the Amount (in US$) in Nepal in 2001 to that in 2004?
Your answer should be very brief. 1.57. What is the ratio of the Amount (in US$) of High income: OECD in 2001 to that in 2005?
Make the answer very short. 0.74. What is the ratio of the Amount (in US$) in Brazil in 2001 to that in 2005?
Provide a short and direct response. 0.37. What is the ratio of the Amount (in US$) in Nepal in 2001 to that in 2005?
Provide a short and direct response. 1.62. What is the ratio of the Amount (in US$) in High income: OECD in 2001 to that in 2006?
Provide a succinct answer. 0.7. What is the ratio of the Amount (in US$) in Brazil in 2001 to that in 2006?
Give a very brief answer. 0.43. What is the ratio of the Amount (in US$) of Nepal in 2001 to that in 2006?
Give a very brief answer. 1.62. What is the ratio of the Amount (in US$) in High income: OECD in 2002 to that in 2003?
Provide a succinct answer. 0.94. What is the ratio of the Amount (in US$) in Brazil in 2002 to that in 2003?
Make the answer very short. 0.74. What is the ratio of the Amount (in US$) of Nepal in 2002 to that in 2003?
Keep it short and to the point. 0.94. What is the ratio of the Amount (in US$) of High income: OECD in 2002 to that in 2004?
Provide a short and direct response. 0.79. What is the ratio of the Amount (in US$) of Brazil in 2002 to that in 2004?
Provide a succinct answer. 0.86. What is the ratio of the Amount (in US$) in High income: OECD in 2002 to that in 2005?
Keep it short and to the point. 0.73. What is the ratio of the Amount (in US$) in Brazil in 2002 to that in 2005?
Offer a very short reply. 0.47. What is the ratio of the Amount (in US$) of Nepal in 2002 to that in 2005?
Your answer should be compact. 1.07. What is the ratio of the Amount (in US$) of High income: OECD in 2002 to that in 2006?
Give a very brief answer. 0.69. What is the ratio of the Amount (in US$) of Brazil in 2002 to that in 2006?
Offer a terse response. 0.55. What is the ratio of the Amount (in US$) in Nepal in 2002 to that in 2006?
Provide a succinct answer. 1.07. What is the ratio of the Amount (in US$) in High income: OECD in 2003 to that in 2004?
Offer a terse response. 0.84. What is the ratio of the Amount (in US$) in Brazil in 2003 to that in 2004?
Your answer should be compact. 1.16. What is the ratio of the Amount (in US$) in Nepal in 2003 to that in 2004?
Your response must be concise. 1.1. What is the ratio of the Amount (in US$) of High income: OECD in 2003 to that in 2005?
Your answer should be compact. 0.78. What is the ratio of the Amount (in US$) in Brazil in 2003 to that in 2005?
Offer a terse response. 0.63. What is the ratio of the Amount (in US$) of Nepal in 2003 to that in 2005?
Give a very brief answer. 1.14. What is the ratio of the Amount (in US$) of High income: OECD in 2003 to that in 2006?
Your response must be concise. 0.73. What is the ratio of the Amount (in US$) of Brazil in 2003 to that in 2006?
Offer a terse response. 0.74. What is the ratio of the Amount (in US$) of Nepal in 2003 to that in 2006?
Offer a terse response. 1.14. What is the ratio of the Amount (in US$) of High income: OECD in 2004 to that in 2005?
Give a very brief answer. 0.93. What is the ratio of the Amount (in US$) of Brazil in 2004 to that in 2005?
Provide a succinct answer. 0.54. What is the ratio of the Amount (in US$) in Nepal in 2004 to that in 2005?
Give a very brief answer. 1.03. What is the ratio of the Amount (in US$) in High income: OECD in 2004 to that in 2006?
Make the answer very short. 0.87. What is the ratio of the Amount (in US$) of Brazil in 2004 to that in 2006?
Your answer should be very brief. 0.64. What is the ratio of the Amount (in US$) of Nepal in 2004 to that in 2006?
Provide a short and direct response. 1.03. What is the ratio of the Amount (in US$) of High income: OECD in 2005 to that in 2006?
Your response must be concise. 0.94. What is the ratio of the Amount (in US$) of Brazil in 2005 to that in 2006?
Keep it short and to the point. 1.18. What is the difference between the highest and the second highest Amount (in US$) in High income: OECD?
Your answer should be very brief. 6.23e+09. What is the difference between the highest and the second highest Amount (in US$) in Brazil?
Provide a short and direct response. 4.60e+07. What is the difference between the highest and the lowest Amount (in US$) in High income: OECD?
Offer a terse response. 3.05e+1. What is the difference between the highest and the lowest Amount (in US$) in Brazil?
Ensure brevity in your answer.  2.15e+08. What is the difference between the highest and the lowest Amount (in US$) of Nepal?
Keep it short and to the point. 3.20e+07. 